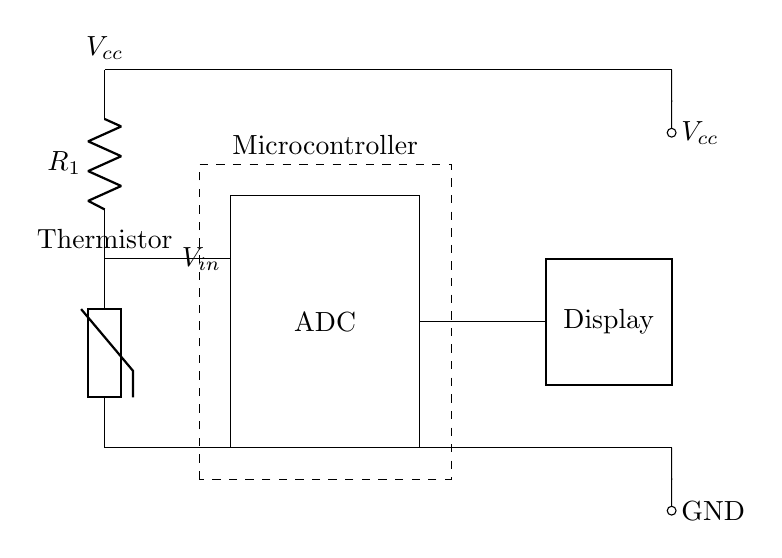What type of sensor is used in this circuit? The circuit uses a thermistor as the temperature sensor, which can change its resistance based on temperature.
Answer: Thermistor What is connected to the ADC input? The ADC input is connected to the output of the thermistor voltage divider formed by the thermistor and resistor R1.
Answer: Thermistor output What is the significance of Vcc in this circuit? Vcc provides the power supply voltage that is necessary for the circuit components to operate correctly, especially for the ADC and microcontroller.
Answer: Power supply voltage What does the rectangle labeled "ADC" represent? The rectangle labeled "ADC" represents the analog-to-digital converter, which converts the analog voltage from the thermistor into a digital value that can be processed by the microcontroller.
Answer: Analog-to-digital converter How many output components does the circuit have? The circuit contains one output component, which is the digital display that shows the temperature readings.
Answer: One What is the purpose of the voltage divider in this circuit? The voltage divider, made up of the thermistor and resistor R1, adjusts the input voltage to the ADC to a suitable level for accurate digital conversion based on the thermistor's resistance changes.
Answer: Adjust input voltage What role does the microcontroller play in this circuit? The microcontroller processes the digital output from the ADC and controls the display to show the temperature readings accordingly.
Answer: Processes data 